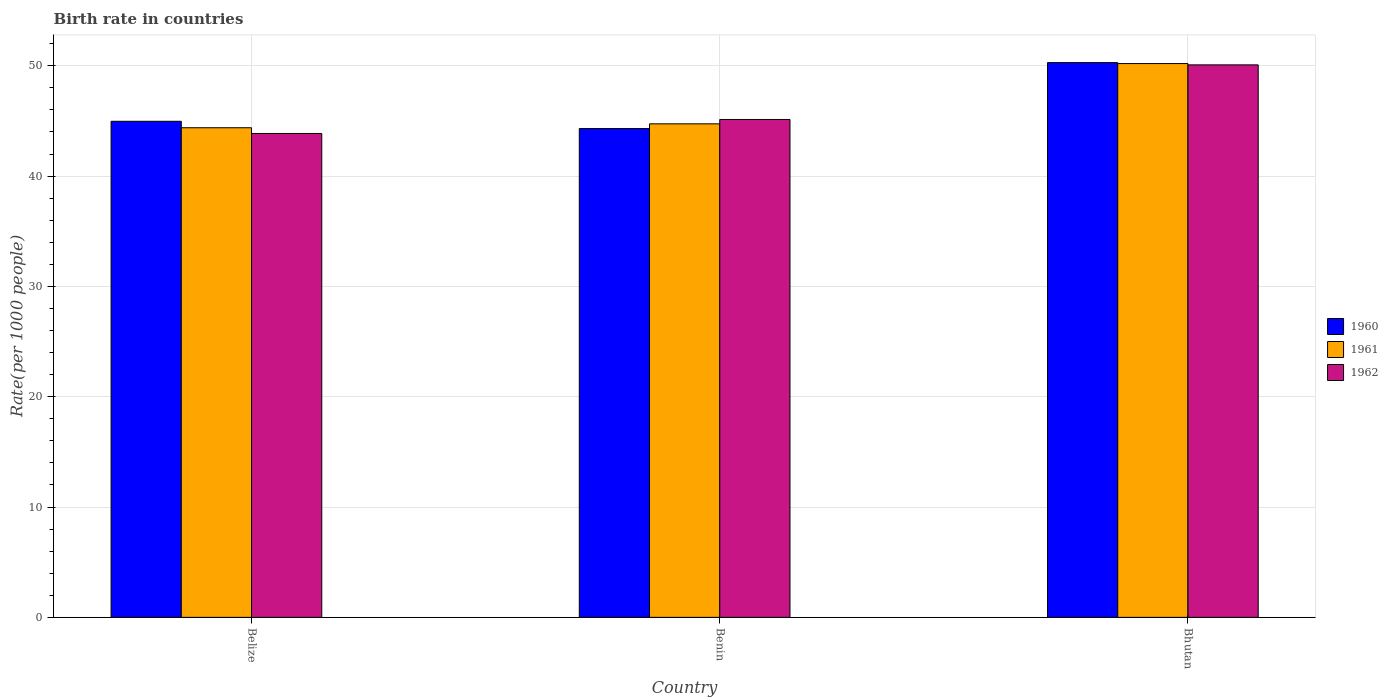How many groups of bars are there?
Provide a succinct answer. 3. What is the label of the 1st group of bars from the left?
Keep it short and to the point. Belize. What is the birth rate in 1961 in Bhutan?
Give a very brief answer. 50.2. Across all countries, what is the maximum birth rate in 1962?
Keep it short and to the point. 50.08. Across all countries, what is the minimum birth rate in 1962?
Provide a succinct answer. 43.86. In which country was the birth rate in 1960 maximum?
Offer a very short reply. Bhutan. In which country was the birth rate in 1961 minimum?
Provide a succinct answer. Belize. What is the total birth rate in 1961 in the graph?
Provide a succinct answer. 139.32. What is the difference between the birth rate in 1961 in Benin and that in Bhutan?
Offer a very short reply. -5.46. What is the difference between the birth rate in 1961 in Bhutan and the birth rate in 1960 in Belize?
Ensure brevity in your answer.  5.23. What is the average birth rate in 1962 per country?
Your answer should be very brief. 46.36. What is the difference between the birth rate of/in 1961 and birth rate of/in 1962 in Belize?
Offer a terse response. 0.52. What is the ratio of the birth rate in 1961 in Belize to that in Bhutan?
Offer a terse response. 0.88. Is the birth rate in 1962 in Benin less than that in Bhutan?
Your answer should be very brief. Yes. Is the difference between the birth rate in 1961 in Belize and Benin greater than the difference between the birth rate in 1962 in Belize and Benin?
Offer a terse response. Yes. What is the difference between the highest and the second highest birth rate in 1962?
Your response must be concise. 6.22. What is the difference between the highest and the lowest birth rate in 1961?
Make the answer very short. 5.82. Is the sum of the birth rate in 1962 in Benin and Bhutan greater than the maximum birth rate in 1960 across all countries?
Give a very brief answer. Yes. What does the 1st bar from the left in Bhutan represents?
Provide a succinct answer. 1960. What does the 2nd bar from the right in Belize represents?
Ensure brevity in your answer.  1961. Is it the case that in every country, the sum of the birth rate in 1962 and birth rate in 1960 is greater than the birth rate in 1961?
Your answer should be compact. Yes. How many bars are there?
Your response must be concise. 9. Are all the bars in the graph horizontal?
Make the answer very short. No. How many countries are there in the graph?
Give a very brief answer. 3. Are the values on the major ticks of Y-axis written in scientific E-notation?
Your response must be concise. No. Does the graph contain grids?
Provide a succinct answer. Yes. Where does the legend appear in the graph?
Provide a succinct answer. Center right. How many legend labels are there?
Offer a terse response. 3. What is the title of the graph?
Keep it short and to the point. Birth rate in countries. Does "2008" appear as one of the legend labels in the graph?
Keep it short and to the point. No. What is the label or title of the Y-axis?
Offer a very short reply. Rate(per 1000 people). What is the Rate(per 1000 people) of 1960 in Belize?
Keep it short and to the point. 44.97. What is the Rate(per 1000 people) of 1961 in Belize?
Give a very brief answer. 44.38. What is the Rate(per 1000 people) in 1962 in Belize?
Provide a succinct answer. 43.86. What is the Rate(per 1000 people) in 1960 in Benin?
Provide a succinct answer. 44.31. What is the Rate(per 1000 people) of 1961 in Benin?
Your answer should be compact. 44.74. What is the Rate(per 1000 people) in 1962 in Benin?
Ensure brevity in your answer.  45.13. What is the Rate(per 1000 people) of 1960 in Bhutan?
Make the answer very short. 50.29. What is the Rate(per 1000 people) in 1961 in Bhutan?
Offer a very short reply. 50.2. What is the Rate(per 1000 people) of 1962 in Bhutan?
Your answer should be compact. 50.08. Across all countries, what is the maximum Rate(per 1000 people) in 1960?
Offer a terse response. 50.29. Across all countries, what is the maximum Rate(per 1000 people) in 1961?
Ensure brevity in your answer.  50.2. Across all countries, what is the maximum Rate(per 1000 people) of 1962?
Make the answer very short. 50.08. Across all countries, what is the minimum Rate(per 1000 people) in 1960?
Keep it short and to the point. 44.31. Across all countries, what is the minimum Rate(per 1000 people) of 1961?
Offer a very short reply. 44.38. Across all countries, what is the minimum Rate(per 1000 people) in 1962?
Offer a terse response. 43.86. What is the total Rate(per 1000 people) in 1960 in the graph?
Keep it short and to the point. 139.56. What is the total Rate(per 1000 people) of 1961 in the graph?
Your answer should be very brief. 139.32. What is the total Rate(per 1000 people) in 1962 in the graph?
Your answer should be compact. 139.07. What is the difference between the Rate(per 1000 people) in 1960 in Belize and that in Benin?
Offer a very short reply. 0.66. What is the difference between the Rate(per 1000 people) in 1961 in Belize and that in Benin?
Your response must be concise. -0.35. What is the difference between the Rate(per 1000 people) of 1962 in Belize and that in Benin?
Give a very brief answer. -1.27. What is the difference between the Rate(per 1000 people) in 1960 in Belize and that in Bhutan?
Give a very brief answer. -5.32. What is the difference between the Rate(per 1000 people) in 1961 in Belize and that in Bhutan?
Your response must be concise. -5.82. What is the difference between the Rate(per 1000 people) of 1962 in Belize and that in Bhutan?
Provide a short and direct response. -6.22. What is the difference between the Rate(per 1000 people) of 1960 in Benin and that in Bhutan?
Provide a succinct answer. -5.98. What is the difference between the Rate(per 1000 people) in 1961 in Benin and that in Bhutan?
Provide a succinct answer. -5.46. What is the difference between the Rate(per 1000 people) of 1962 in Benin and that in Bhutan?
Your response must be concise. -4.95. What is the difference between the Rate(per 1000 people) in 1960 in Belize and the Rate(per 1000 people) in 1961 in Benin?
Provide a short and direct response. 0.23. What is the difference between the Rate(per 1000 people) in 1960 in Belize and the Rate(per 1000 people) in 1962 in Benin?
Ensure brevity in your answer.  -0.17. What is the difference between the Rate(per 1000 people) in 1961 in Belize and the Rate(per 1000 people) in 1962 in Benin?
Ensure brevity in your answer.  -0.75. What is the difference between the Rate(per 1000 people) of 1960 in Belize and the Rate(per 1000 people) of 1961 in Bhutan?
Keep it short and to the point. -5.23. What is the difference between the Rate(per 1000 people) of 1960 in Belize and the Rate(per 1000 people) of 1962 in Bhutan?
Provide a succinct answer. -5.11. What is the difference between the Rate(per 1000 people) of 1961 in Belize and the Rate(per 1000 people) of 1962 in Bhutan?
Your response must be concise. -5.7. What is the difference between the Rate(per 1000 people) in 1960 in Benin and the Rate(per 1000 people) in 1961 in Bhutan?
Your response must be concise. -5.89. What is the difference between the Rate(per 1000 people) in 1960 in Benin and the Rate(per 1000 people) in 1962 in Bhutan?
Offer a terse response. -5.77. What is the difference between the Rate(per 1000 people) in 1961 in Benin and the Rate(per 1000 people) in 1962 in Bhutan?
Make the answer very short. -5.34. What is the average Rate(per 1000 people) in 1960 per country?
Give a very brief answer. 46.52. What is the average Rate(per 1000 people) of 1961 per country?
Provide a short and direct response. 46.44. What is the average Rate(per 1000 people) of 1962 per country?
Offer a terse response. 46.36. What is the difference between the Rate(per 1000 people) in 1960 and Rate(per 1000 people) in 1961 in Belize?
Offer a terse response. 0.58. What is the difference between the Rate(per 1000 people) of 1960 and Rate(per 1000 people) of 1962 in Belize?
Offer a very short reply. 1.1. What is the difference between the Rate(per 1000 people) of 1961 and Rate(per 1000 people) of 1962 in Belize?
Make the answer very short. 0.52. What is the difference between the Rate(per 1000 people) in 1960 and Rate(per 1000 people) in 1961 in Benin?
Provide a short and direct response. -0.43. What is the difference between the Rate(per 1000 people) of 1960 and Rate(per 1000 people) of 1962 in Benin?
Your answer should be very brief. -0.82. What is the difference between the Rate(per 1000 people) of 1961 and Rate(per 1000 people) of 1962 in Benin?
Give a very brief answer. -0.4. What is the difference between the Rate(per 1000 people) in 1960 and Rate(per 1000 people) in 1961 in Bhutan?
Provide a short and direct response. 0.09. What is the difference between the Rate(per 1000 people) in 1960 and Rate(per 1000 people) in 1962 in Bhutan?
Your response must be concise. 0.2. What is the difference between the Rate(per 1000 people) of 1961 and Rate(per 1000 people) of 1962 in Bhutan?
Ensure brevity in your answer.  0.12. What is the ratio of the Rate(per 1000 people) in 1960 in Belize to that in Benin?
Offer a terse response. 1.01. What is the ratio of the Rate(per 1000 people) of 1961 in Belize to that in Benin?
Make the answer very short. 0.99. What is the ratio of the Rate(per 1000 people) of 1962 in Belize to that in Benin?
Provide a short and direct response. 0.97. What is the ratio of the Rate(per 1000 people) in 1960 in Belize to that in Bhutan?
Provide a short and direct response. 0.89. What is the ratio of the Rate(per 1000 people) in 1961 in Belize to that in Bhutan?
Your answer should be very brief. 0.88. What is the ratio of the Rate(per 1000 people) in 1962 in Belize to that in Bhutan?
Provide a short and direct response. 0.88. What is the ratio of the Rate(per 1000 people) of 1960 in Benin to that in Bhutan?
Ensure brevity in your answer.  0.88. What is the ratio of the Rate(per 1000 people) in 1961 in Benin to that in Bhutan?
Provide a short and direct response. 0.89. What is the ratio of the Rate(per 1000 people) in 1962 in Benin to that in Bhutan?
Give a very brief answer. 0.9. What is the difference between the highest and the second highest Rate(per 1000 people) in 1960?
Your answer should be compact. 5.32. What is the difference between the highest and the second highest Rate(per 1000 people) of 1961?
Make the answer very short. 5.46. What is the difference between the highest and the second highest Rate(per 1000 people) in 1962?
Make the answer very short. 4.95. What is the difference between the highest and the lowest Rate(per 1000 people) of 1960?
Offer a terse response. 5.98. What is the difference between the highest and the lowest Rate(per 1000 people) in 1961?
Ensure brevity in your answer.  5.82. What is the difference between the highest and the lowest Rate(per 1000 people) in 1962?
Ensure brevity in your answer.  6.22. 